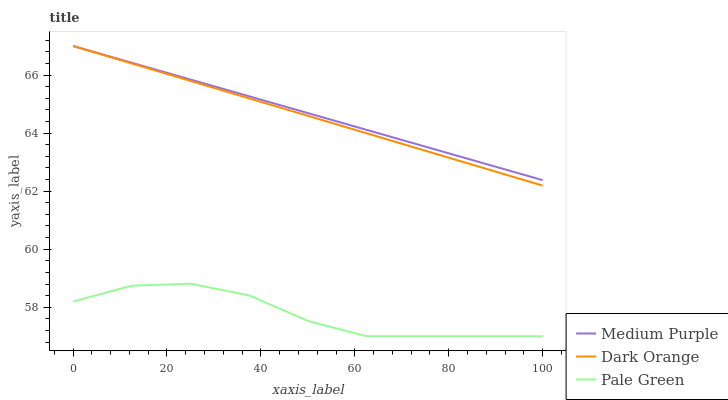Does Pale Green have the minimum area under the curve?
Answer yes or no. Yes. Does Medium Purple have the maximum area under the curve?
Answer yes or no. Yes. Does Dark Orange have the minimum area under the curve?
Answer yes or no. No. Does Dark Orange have the maximum area under the curve?
Answer yes or no. No. Is Dark Orange the smoothest?
Answer yes or no. Yes. Is Pale Green the roughest?
Answer yes or no. Yes. Is Pale Green the smoothest?
Answer yes or no. No. Is Dark Orange the roughest?
Answer yes or no. No. Does Pale Green have the lowest value?
Answer yes or no. Yes. Does Dark Orange have the lowest value?
Answer yes or no. No. Does Dark Orange have the highest value?
Answer yes or no. Yes. Does Pale Green have the highest value?
Answer yes or no. No. Is Pale Green less than Dark Orange?
Answer yes or no. Yes. Is Dark Orange greater than Pale Green?
Answer yes or no. Yes. Does Dark Orange intersect Medium Purple?
Answer yes or no. Yes. Is Dark Orange less than Medium Purple?
Answer yes or no. No. Is Dark Orange greater than Medium Purple?
Answer yes or no. No. Does Pale Green intersect Dark Orange?
Answer yes or no. No. 